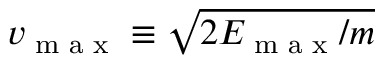<formula> <loc_0><loc_0><loc_500><loc_500>v _ { \max } \equiv \sqrt { 2 E _ { \max } / m }</formula> 